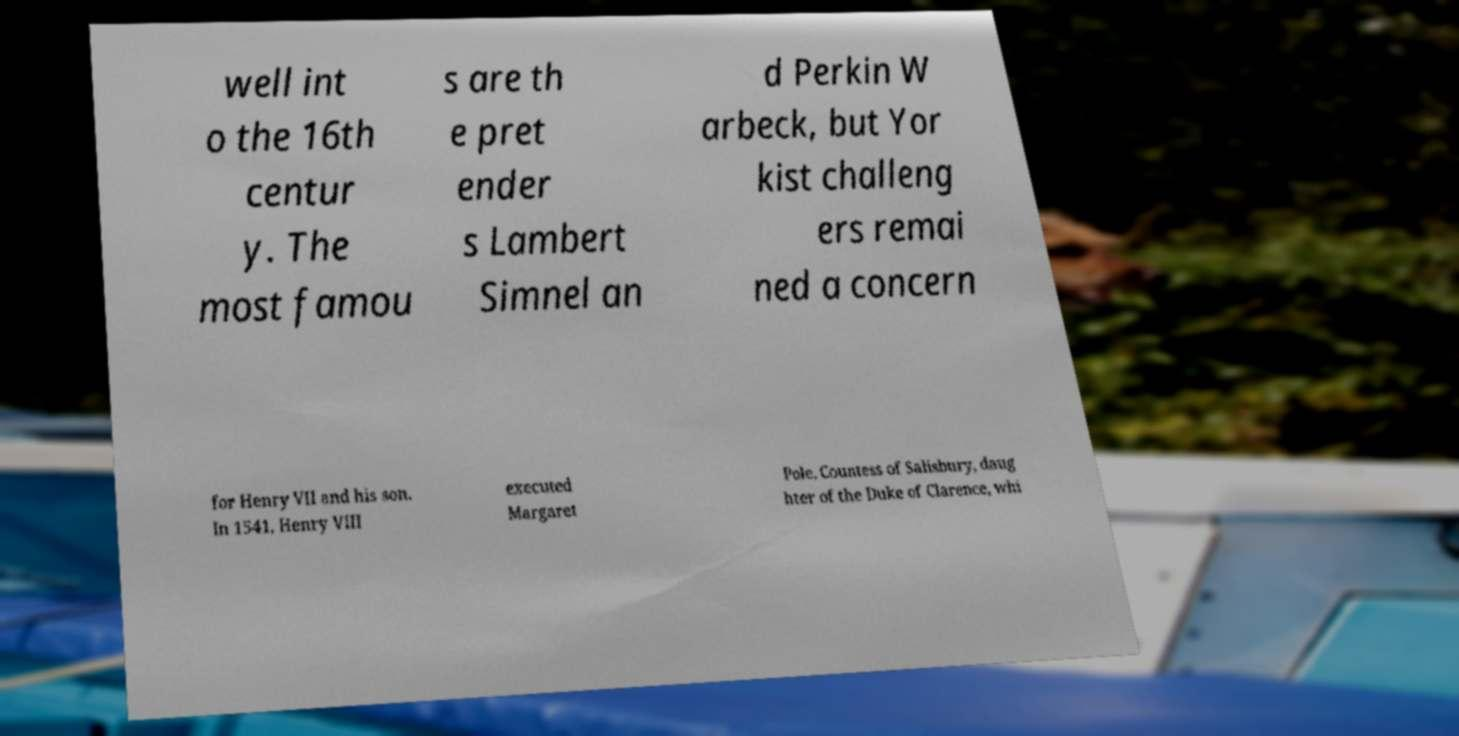I need the written content from this picture converted into text. Can you do that? well int o the 16th centur y. The most famou s are th e pret ender s Lambert Simnel an d Perkin W arbeck, but Yor kist challeng ers remai ned a concern for Henry VII and his son. In 1541, Henry VIII executed Margaret Pole, Countess of Salisbury, daug hter of the Duke of Clarence, whi 